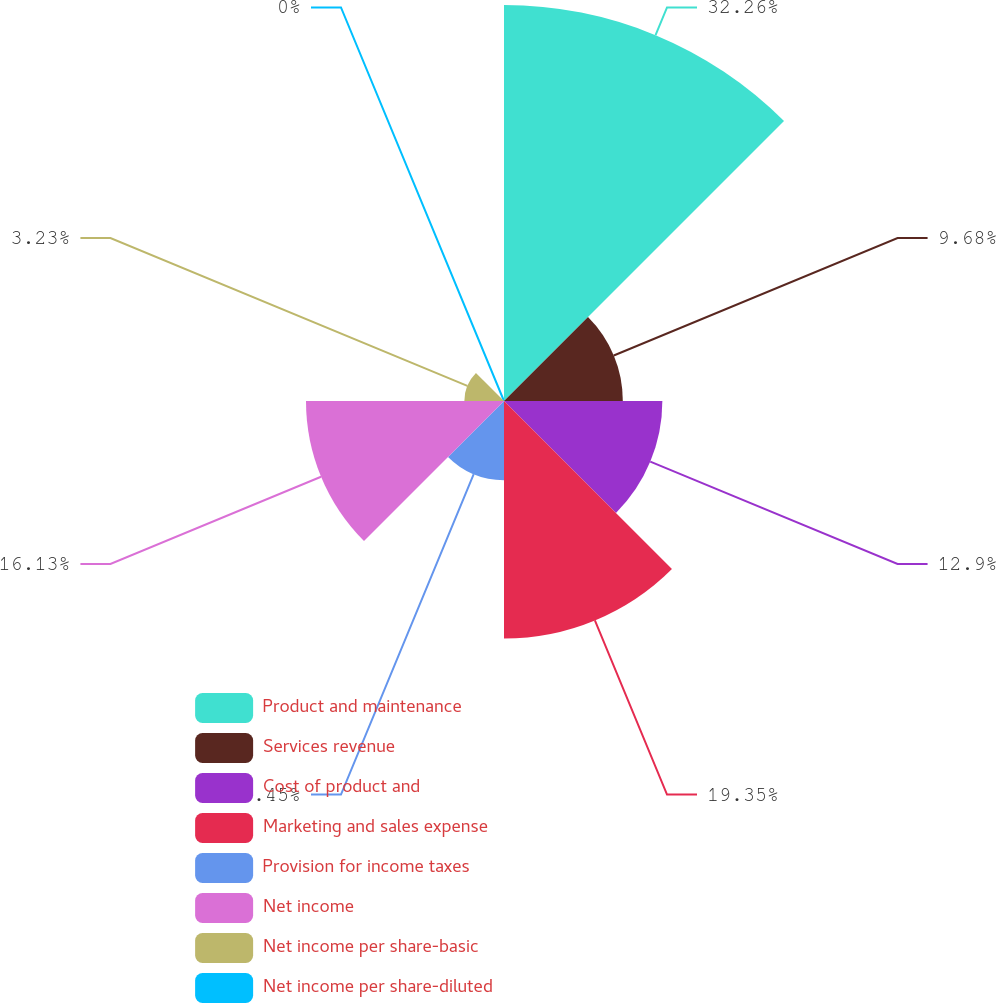Convert chart to OTSL. <chart><loc_0><loc_0><loc_500><loc_500><pie_chart><fcel>Product and maintenance<fcel>Services revenue<fcel>Cost of product and<fcel>Marketing and sales expense<fcel>Provision for income taxes<fcel>Net income<fcel>Net income per share-basic<fcel>Net income per share-diluted<nl><fcel>32.26%<fcel>9.68%<fcel>12.9%<fcel>19.35%<fcel>6.45%<fcel>16.13%<fcel>3.23%<fcel>0.0%<nl></chart> 